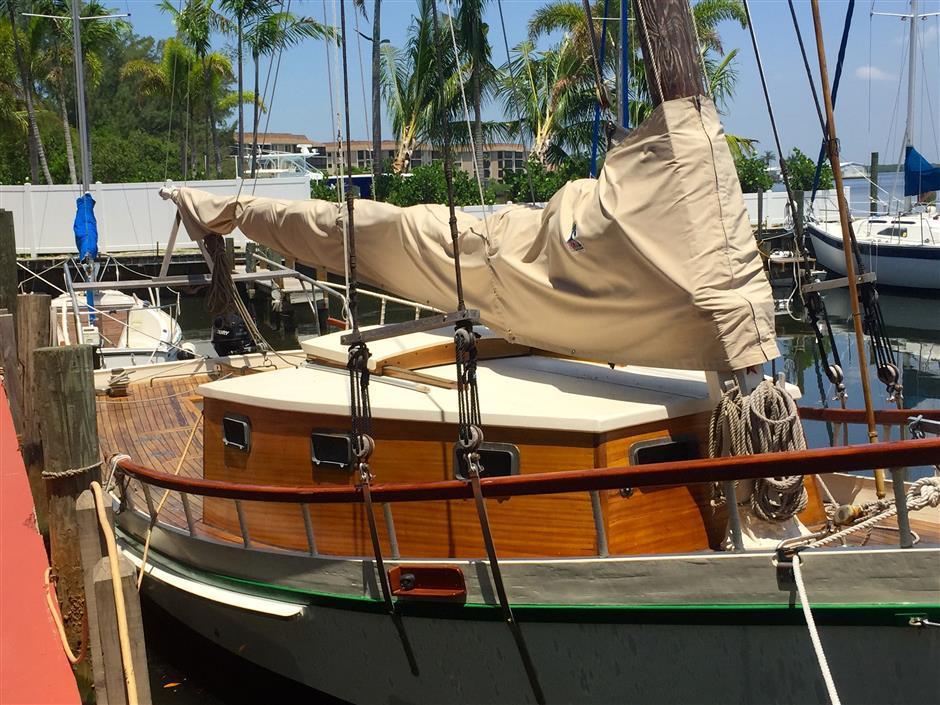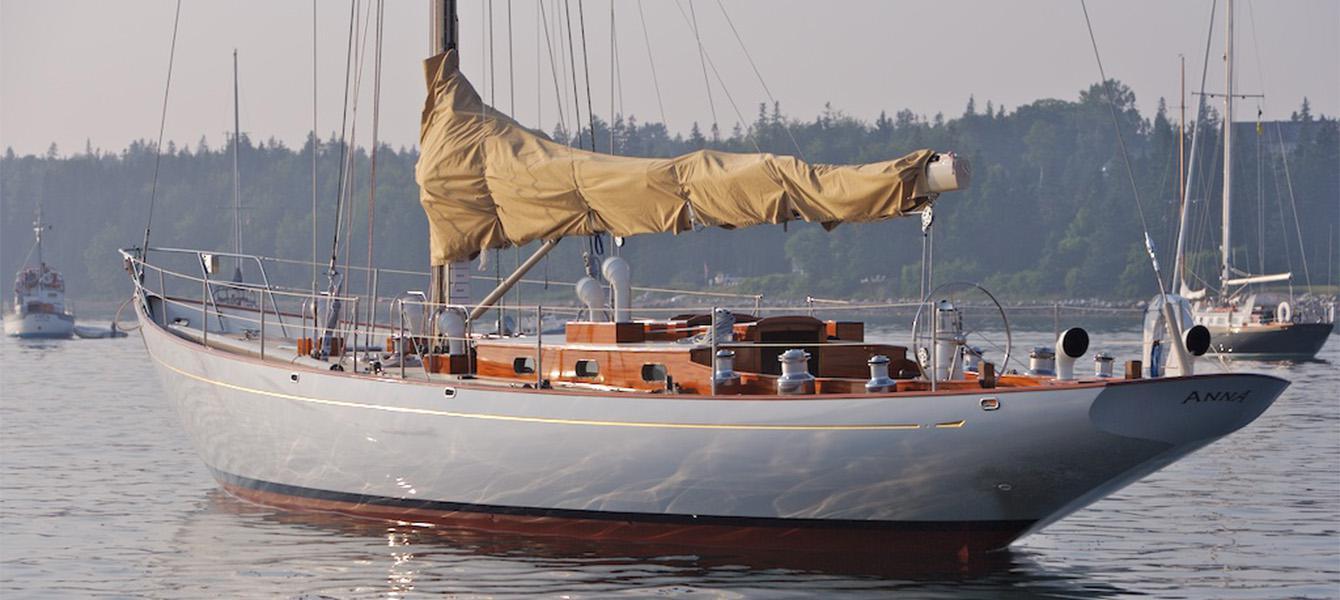The first image is the image on the left, the second image is the image on the right. Assess this claim about the two images: "Both vessels are moving in the same direction.". Correct or not? Answer yes or no. No. The first image is the image on the left, the second image is the image on the right. For the images displayed, is the sentence "The sails of at least one boat are furled in tan canvas." factually correct? Answer yes or no. Yes. 